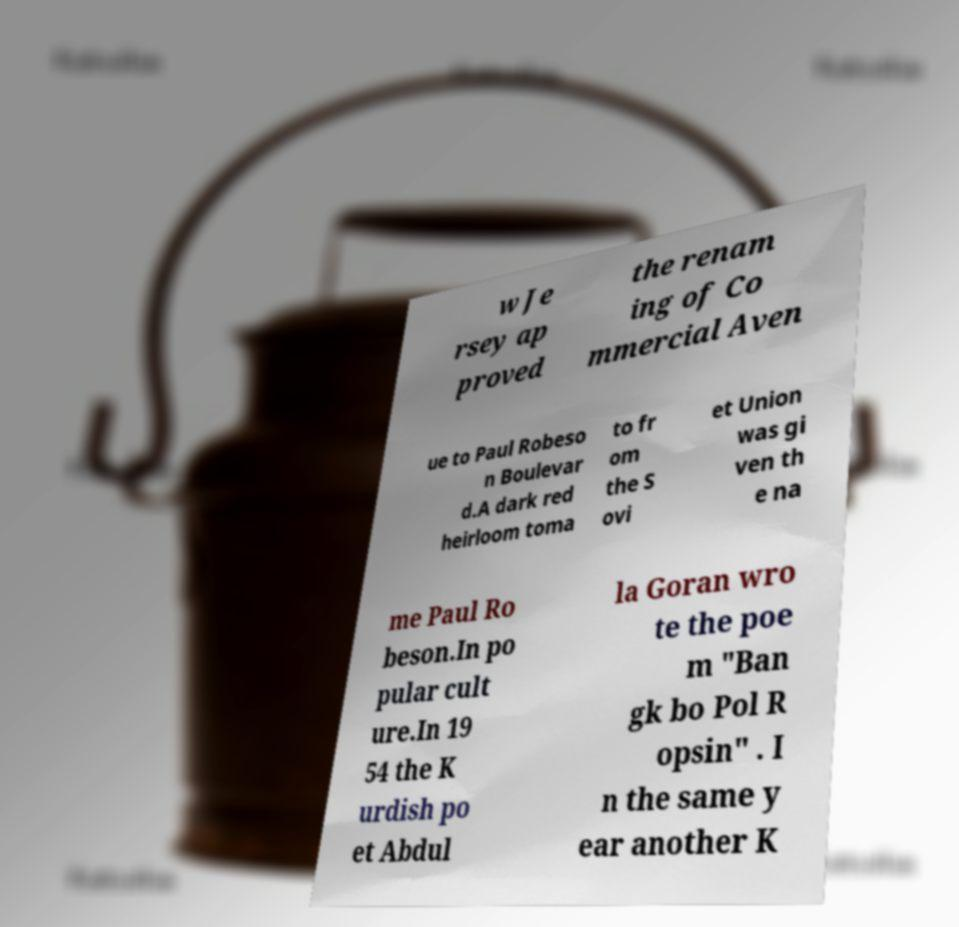Can you accurately transcribe the text from the provided image for me? w Je rsey ap proved the renam ing of Co mmercial Aven ue to Paul Robeso n Boulevar d.A dark red heirloom toma to fr om the S ovi et Union was gi ven th e na me Paul Ro beson.In po pular cult ure.In 19 54 the K urdish po et Abdul la Goran wro te the poe m "Ban gk bo Pol R opsin" . I n the same y ear another K 